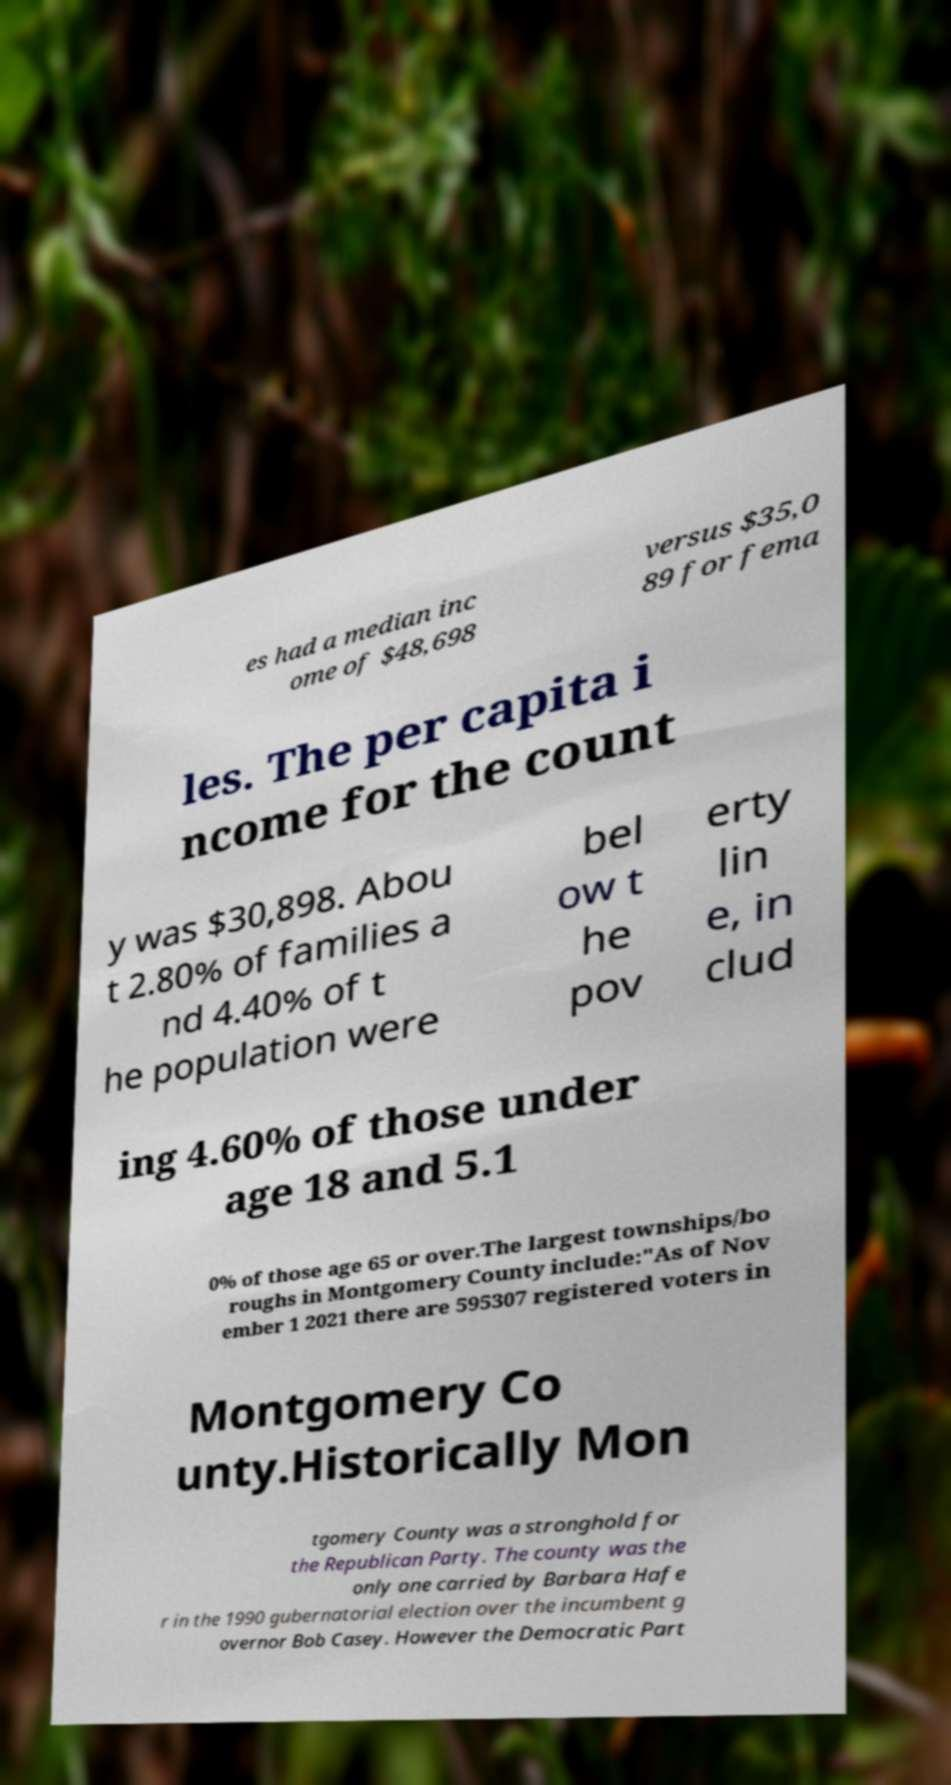Please identify and transcribe the text found in this image. es had a median inc ome of $48,698 versus $35,0 89 for fema les. The per capita i ncome for the count y was $30,898. Abou t 2.80% of families a nd 4.40% of t he population were bel ow t he pov erty lin e, in clud ing 4.60% of those under age 18 and 5.1 0% of those age 65 or over.The largest townships/bo roughs in Montgomery County include:"As of Nov ember 1 2021 there are 595307 registered voters in Montgomery Co unty.Historically Mon tgomery County was a stronghold for the Republican Party. The county was the only one carried by Barbara Hafe r in the 1990 gubernatorial election over the incumbent g overnor Bob Casey. However the Democratic Part 